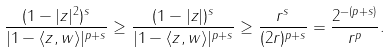Convert formula to latex. <formula><loc_0><loc_0><loc_500><loc_500>\frac { ( 1 - | z | ^ { 2 } ) ^ { s } } { | 1 - \langle z , w \rangle | ^ { p + s } } \geq \frac { ( 1 - | z | ) ^ { s } } { | 1 - \langle z , w \rangle | ^ { p + s } } \geq \frac { r ^ { s } } { ( 2 r ) ^ { p + s } } = \frac { 2 ^ { - ( p + s ) } } { r ^ { p } } .</formula> 